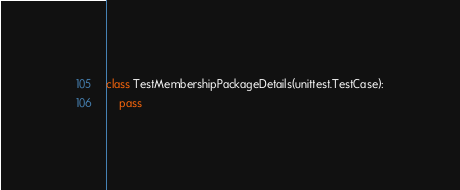<code> <loc_0><loc_0><loc_500><loc_500><_Python_>class TestMembershipPackageDetails(unittest.TestCase):
	pass
</code> 